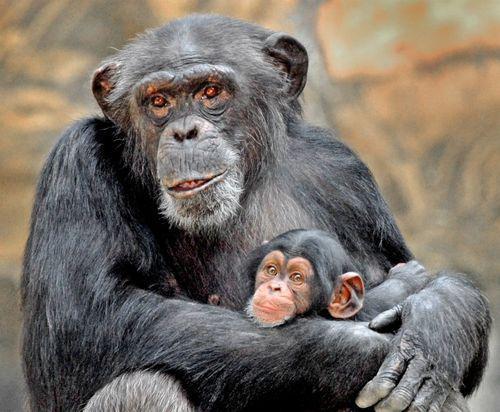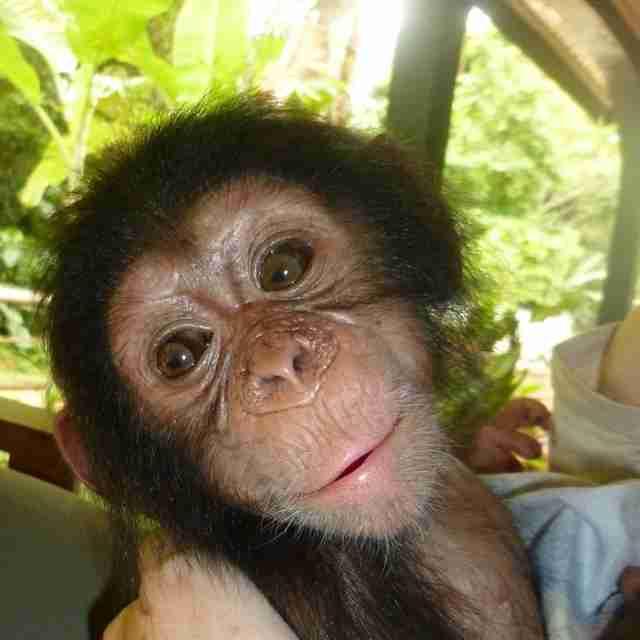The first image is the image on the left, the second image is the image on the right. Assess this claim about the two images: "A mother chimpanzee is holding a baby chimpanzee in her arms in one or the images.". Correct or not? Answer yes or no. Yes. The first image is the image on the left, the second image is the image on the right. Evaluate the accuracy of this statement regarding the images: "A image shows a sitting mother chimp holding a baby chimp.". Is it true? Answer yes or no. Yes. 